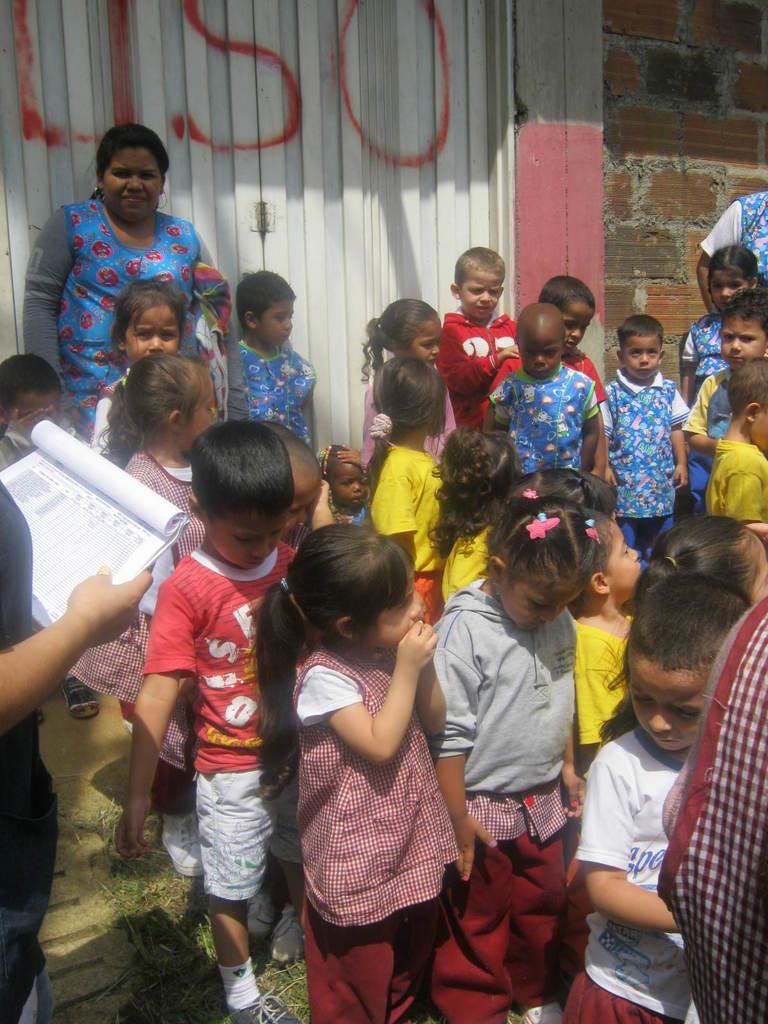What is the main subject of the image? The main subject of the image is a crowd of children. Where are the children located in the image? The children are standing on the ground. Can you describe the person on the left side of the image? The person is holding a book in their hand. What can be seen in the background of the image? There is a wall in the background of the image. What type of design is the farmer using to grow crops in the image? There is no farmer or crops present in the image; it features a crowd of children and a person holding a book. 